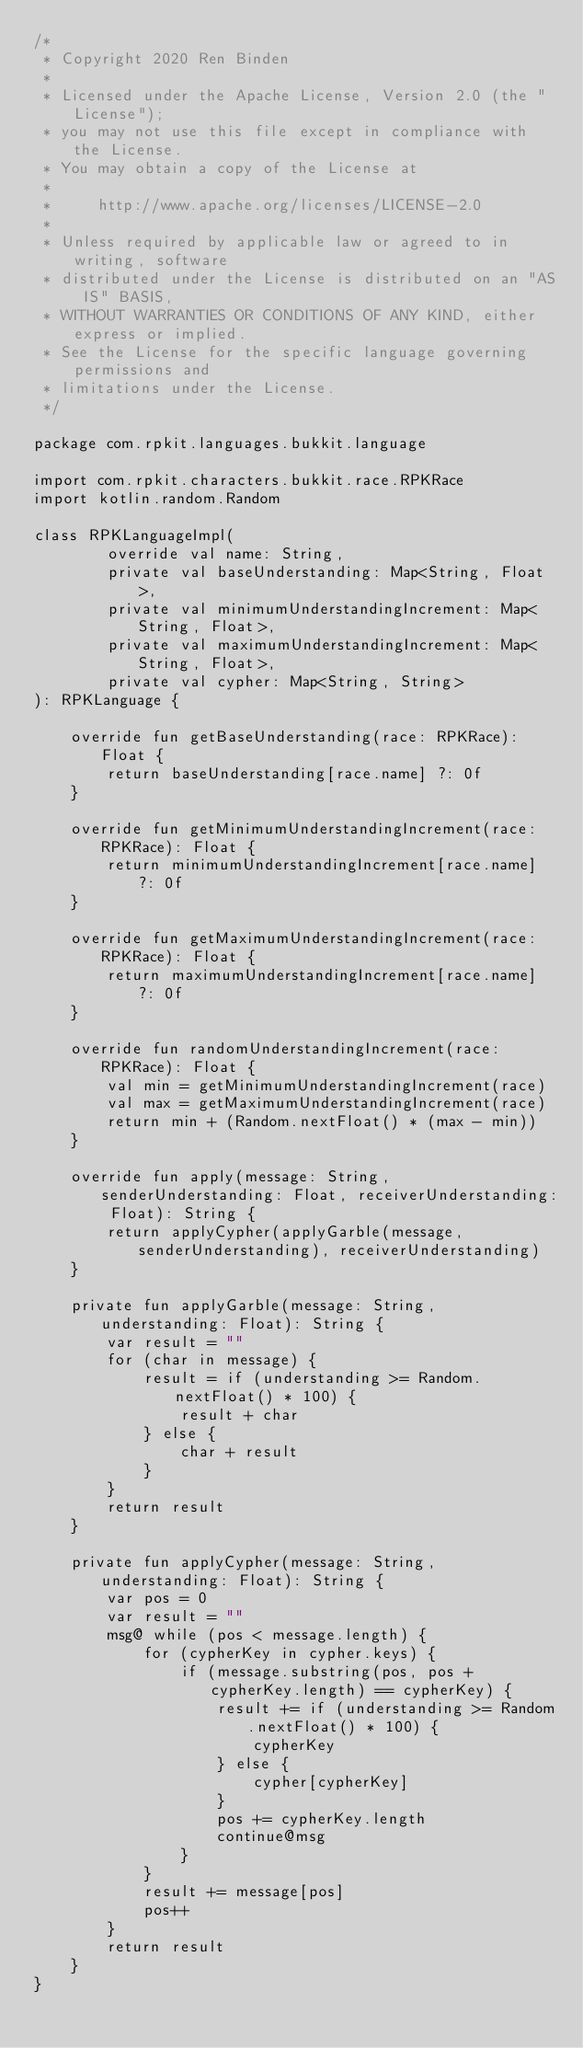<code> <loc_0><loc_0><loc_500><loc_500><_Kotlin_>/*
 * Copyright 2020 Ren Binden
 *
 * Licensed under the Apache License, Version 2.0 (the "License");
 * you may not use this file except in compliance with the License.
 * You may obtain a copy of the License at
 *
 *     http://www.apache.org/licenses/LICENSE-2.0
 *
 * Unless required by applicable law or agreed to in writing, software
 * distributed under the License is distributed on an "AS IS" BASIS,
 * WITHOUT WARRANTIES OR CONDITIONS OF ANY KIND, either express or implied.
 * See the License for the specific language governing permissions and
 * limitations under the License.
 */

package com.rpkit.languages.bukkit.language

import com.rpkit.characters.bukkit.race.RPKRace
import kotlin.random.Random

class RPKLanguageImpl(
        override val name: String,
        private val baseUnderstanding: Map<String, Float>,
        private val minimumUnderstandingIncrement: Map<String, Float>,
        private val maximumUnderstandingIncrement: Map<String, Float>,
        private val cypher: Map<String, String>
): RPKLanguage {

    override fun getBaseUnderstanding(race: RPKRace): Float {
        return baseUnderstanding[race.name] ?: 0f
    }

    override fun getMinimumUnderstandingIncrement(race: RPKRace): Float {
        return minimumUnderstandingIncrement[race.name] ?: 0f
    }

    override fun getMaximumUnderstandingIncrement(race: RPKRace): Float {
        return maximumUnderstandingIncrement[race.name] ?: 0f
    }

    override fun randomUnderstandingIncrement(race: RPKRace): Float {
        val min = getMinimumUnderstandingIncrement(race)
        val max = getMaximumUnderstandingIncrement(race)
        return min + (Random.nextFloat() * (max - min))
    }

    override fun apply(message: String, senderUnderstanding: Float, receiverUnderstanding: Float): String {
        return applyCypher(applyGarble(message, senderUnderstanding), receiverUnderstanding)
    }

    private fun applyGarble(message: String, understanding: Float): String {
        var result = ""
        for (char in message) {
            result = if (understanding >= Random.nextFloat() * 100) {
                result + char
            } else {
                char + result
            }
        }
        return result
    }

    private fun applyCypher(message: String, understanding: Float): String {
        var pos = 0
        var result = ""
        msg@ while (pos < message.length) {
            for (cypherKey in cypher.keys) {
                if (message.substring(pos, pos + cypherKey.length) == cypherKey) {
                    result += if (understanding >= Random.nextFloat() * 100) {
                        cypherKey
                    } else {
                        cypher[cypherKey]
                    }
                    pos += cypherKey.length
                    continue@msg
                }
            }
            result += message[pos]
            pos++
        }
        return result
    }
}</code> 